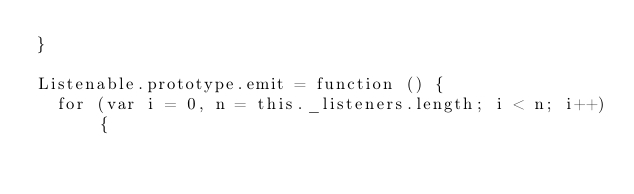Convert code to text. <code><loc_0><loc_0><loc_500><loc_500><_JavaScript_>}

Listenable.prototype.emit = function () {
	for (var i = 0, n = this._listeners.length; i < n; i++) {</code> 